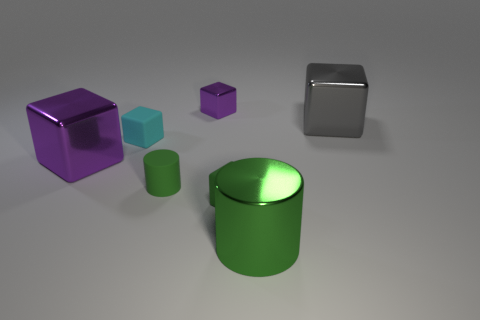There is a purple shiny object right of the matte block behind the large metal object on the left side of the green metal cylinder; what shape is it?
Offer a very short reply. Cube. What material is the block that is both in front of the tiny cyan matte block and left of the tiny purple cube?
Offer a very short reply. Metal. There is a tiny thing right of the metallic cube behind the large gray block; what is its shape?
Keep it short and to the point. Cube. Are there any other things that are the same color as the small cylinder?
Your answer should be very brief. Yes. Is the size of the cyan matte block the same as the rubber cube in front of the small green matte cylinder?
Provide a short and direct response. Yes. How many big objects are either green rubber objects or green matte cubes?
Provide a succinct answer. 0. Are there more big purple blocks than big brown metallic cylinders?
Your answer should be compact. Yes. How many blocks are behind the purple metal block that is in front of the metallic cube that is on the right side of the large green object?
Give a very brief answer. 3. What shape is the big purple object?
Make the answer very short. Cube. What number of other objects are there of the same material as the tiny green cylinder?
Provide a succinct answer. 2. 